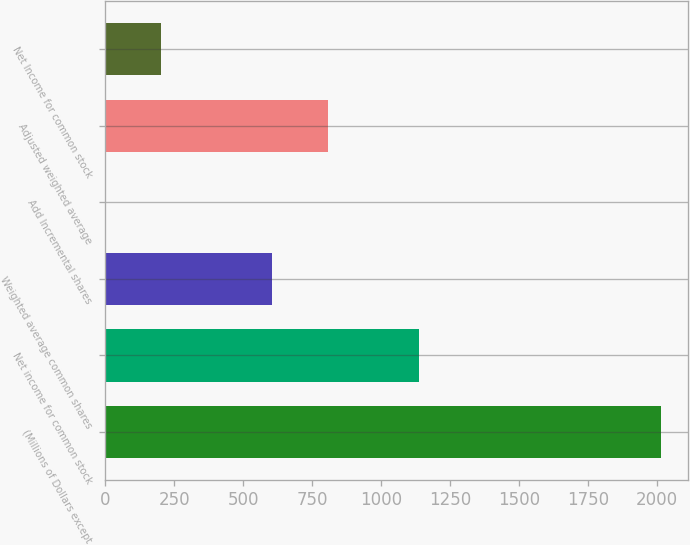<chart> <loc_0><loc_0><loc_500><loc_500><bar_chart><fcel>(Millions of Dollars except<fcel>Net income for common stock<fcel>Weighted average common shares<fcel>Add Incremental shares<fcel>Adjusted weighted average<fcel>Net Income for common stock<nl><fcel>2012<fcel>1138<fcel>604.72<fcel>1.6<fcel>805.76<fcel>202.64<nl></chart> 